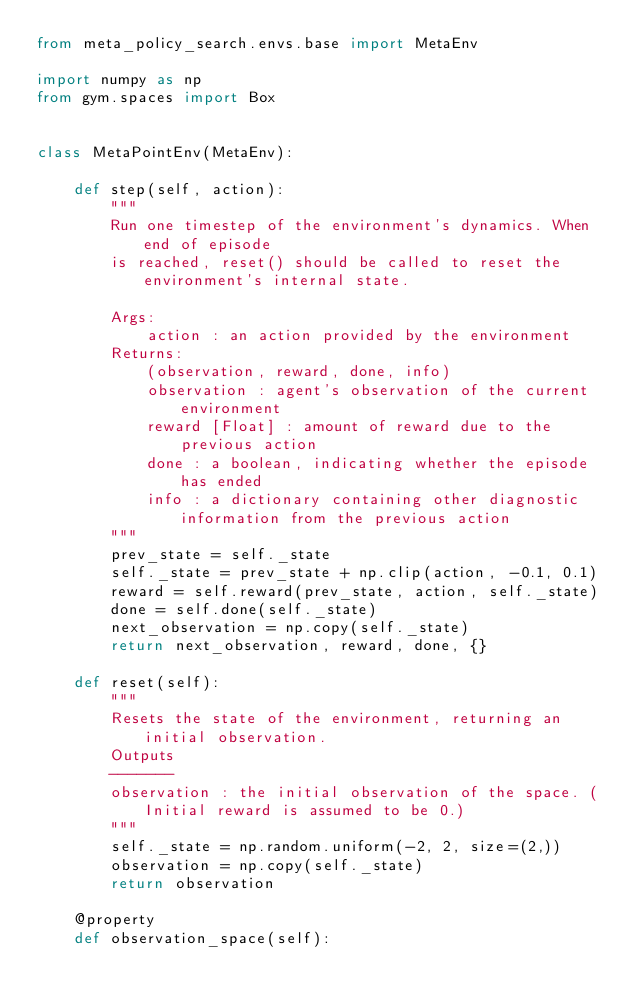Convert code to text. <code><loc_0><loc_0><loc_500><loc_500><_Python_>from meta_policy_search.envs.base import MetaEnv

import numpy as np
from gym.spaces import Box


class MetaPointEnv(MetaEnv):

    def step(self, action):
        """
        Run one timestep of the environment's dynamics. When end of episode
        is reached, reset() should be called to reset the environment's internal state.

        Args:
            action : an action provided by the environment
        Returns:
            (observation, reward, done, info)
            observation : agent's observation of the current environment
            reward [Float] : amount of reward due to the previous action
            done : a boolean, indicating whether the episode has ended
            info : a dictionary containing other diagnostic information from the previous action
        """
        prev_state = self._state
        self._state = prev_state + np.clip(action, -0.1, 0.1)
        reward = self.reward(prev_state, action, self._state)
        done = self.done(self._state)
        next_observation = np.copy(self._state)
        return next_observation, reward, done, {}

    def reset(self):
        """
        Resets the state of the environment, returning an initial observation.
        Outputs
        -------
        observation : the initial observation of the space. (Initial reward is assumed to be 0.)
        """
        self._state = np.random.uniform(-2, 2, size=(2,))
        observation = np.copy(self._state)
        return observation

    @property
    def observation_space(self):</code> 